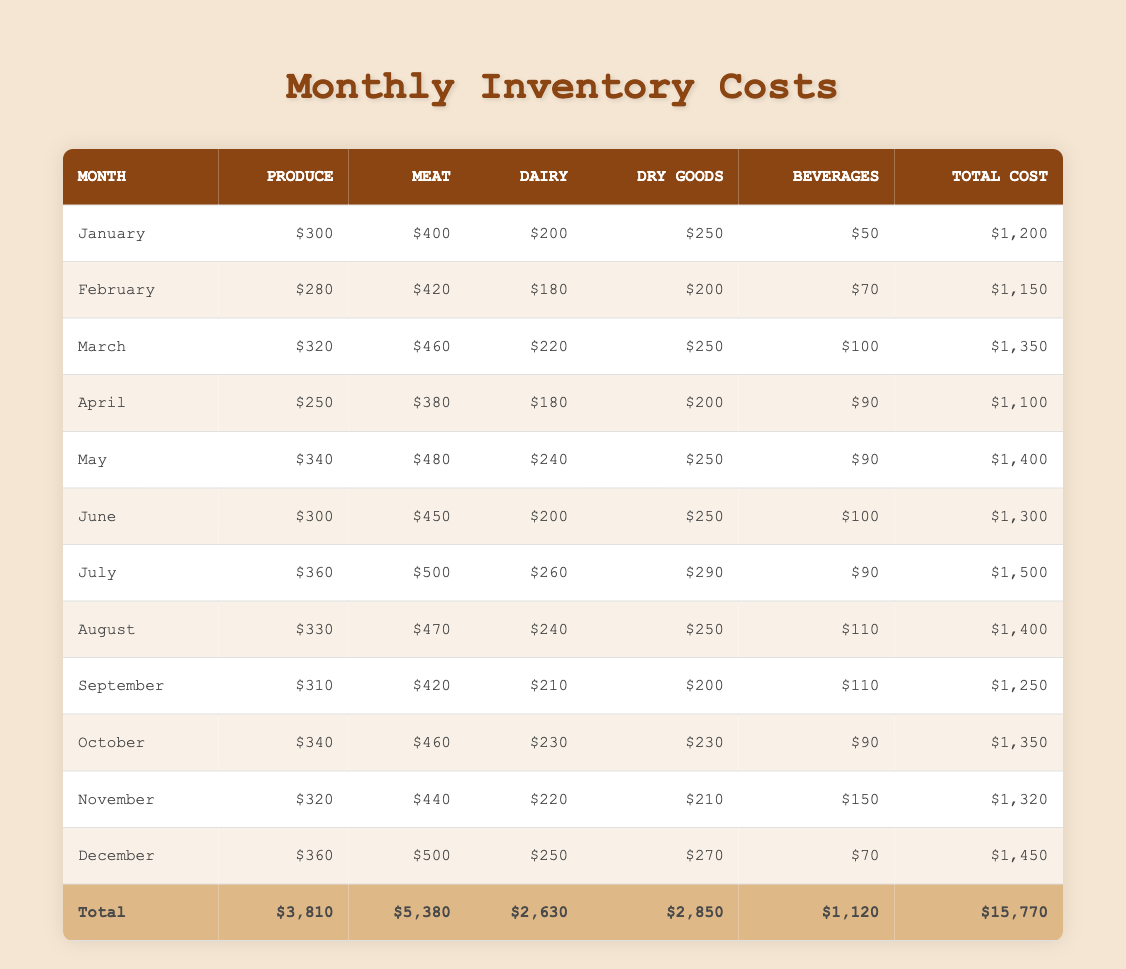What was the total inventory cost in August? The table shows the total inventory cost for each month. In August, the total cost is listed as $1,400.
Answer: $1,400 Which month had the highest meat cost? Looking through the "meat" column, the highest value is $500, which occurs in July.
Answer: July What is the total cost of produce over the year? To find the total produce cost, we sum all produce costs: 300 + 280 + 320 + 250 + 340 + 300 + 360 + 330 + 310 + 340 + 320 + 360 = 3,810.
Answer: $3,810 Did the total inventory cost exceed $1,500 in any month? We check the total costs for each month. The highest total is $1,500 in July, so yes, it did exceed that amount.
Answer: Yes What is the average monthly cost of dry goods? Sum up the dry goods costs: 250 + 200 + 250 + 200 + 250 + 250 + 290 + 250 + 200 + 230 + 210 + 270 = 2,850. Then divide by 12 (total months): 2,850 / 12 = 237.5.
Answer: $237.50 Which month had the lowest total cost, and what was that cost? Scanning the total costs in the table, April has the lowest total cost at $1,100.
Answer: April; $1,100 What was the difference in total cost between January and March? The total cost in January is $1,200, and in March it is $1,350. To find the difference, subtract January's cost from March's: 1,350 - 1,200 = 150.
Answer: $150 Which category had the highest total expenditure for the year? Calculating the totals for each category: Produce = $3,810, Meat = $5,380, Dairy = $2,630, Dry Goods = $2,850, Beverages = $1,120. The highest is meat at $5,380.
Answer: Meat What is the median cost of beverages throughout the year? To find the median, list the beverage costs in order: 50, 70, 90, 90, 100, 100, 110, 110, 150, 70. There are 12 values, so the median is the average of the 6th and 7th values: (100 + 110) / 2 = 105.
Answer: $105 